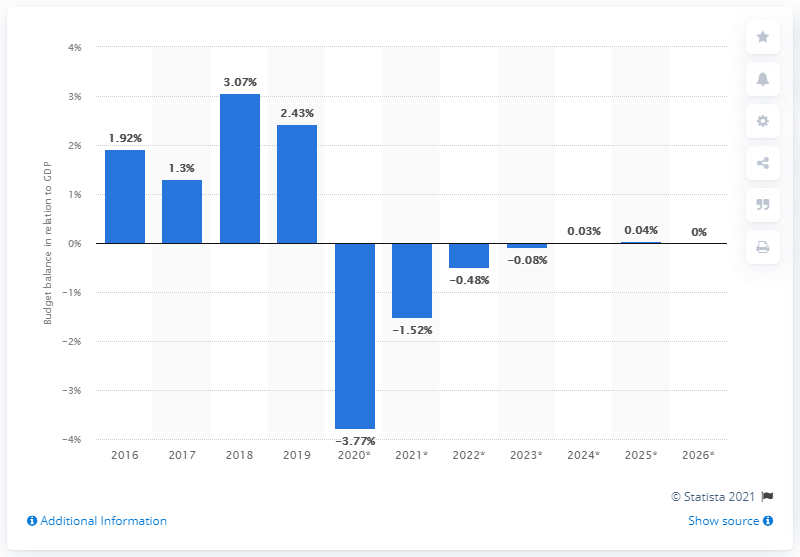Indicate a few pertinent items in this graphic. Luxembourg's budget surplus in 2019 was 2.43 times its GDP, according to recent data. 